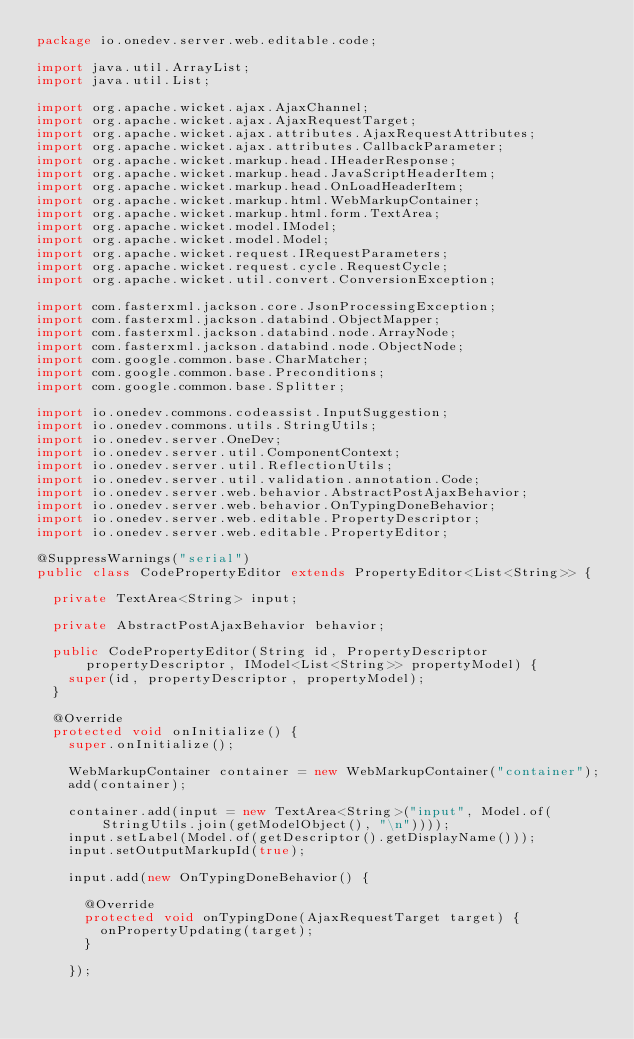Convert code to text. <code><loc_0><loc_0><loc_500><loc_500><_Java_>package io.onedev.server.web.editable.code;

import java.util.ArrayList;
import java.util.List;

import org.apache.wicket.ajax.AjaxChannel;
import org.apache.wicket.ajax.AjaxRequestTarget;
import org.apache.wicket.ajax.attributes.AjaxRequestAttributes;
import org.apache.wicket.ajax.attributes.CallbackParameter;
import org.apache.wicket.markup.head.IHeaderResponse;
import org.apache.wicket.markup.head.JavaScriptHeaderItem;
import org.apache.wicket.markup.head.OnLoadHeaderItem;
import org.apache.wicket.markup.html.WebMarkupContainer;
import org.apache.wicket.markup.html.form.TextArea;
import org.apache.wicket.model.IModel;
import org.apache.wicket.model.Model;
import org.apache.wicket.request.IRequestParameters;
import org.apache.wicket.request.cycle.RequestCycle;
import org.apache.wicket.util.convert.ConversionException;

import com.fasterxml.jackson.core.JsonProcessingException;
import com.fasterxml.jackson.databind.ObjectMapper;
import com.fasterxml.jackson.databind.node.ArrayNode;
import com.fasterxml.jackson.databind.node.ObjectNode;
import com.google.common.base.CharMatcher;
import com.google.common.base.Preconditions;
import com.google.common.base.Splitter;

import io.onedev.commons.codeassist.InputSuggestion;
import io.onedev.commons.utils.StringUtils;
import io.onedev.server.OneDev;
import io.onedev.server.util.ComponentContext;
import io.onedev.server.util.ReflectionUtils;
import io.onedev.server.util.validation.annotation.Code;
import io.onedev.server.web.behavior.AbstractPostAjaxBehavior;
import io.onedev.server.web.behavior.OnTypingDoneBehavior;
import io.onedev.server.web.editable.PropertyDescriptor;
import io.onedev.server.web.editable.PropertyEditor;

@SuppressWarnings("serial")
public class CodePropertyEditor extends PropertyEditor<List<String>> {

	private TextArea<String> input;
	
	private AbstractPostAjaxBehavior behavior;
	
	public CodePropertyEditor(String id, PropertyDescriptor propertyDescriptor, IModel<List<String>> propertyModel) {
		super(id, propertyDescriptor, propertyModel);
	}

	@Override
	protected void onInitialize() {
		super.onInitialize();
		
		WebMarkupContainer container = new WebMarkupContainer("container");
		add(container);
		
		container.add(input = new TextArea<String>("input", Model.of(StringUtils.join(getModelObject(), "\n"))));
		input.setLabel(Model.of(getDescriptor().getDisplayName()));		
		input.setOutputMarkupId(true);

		input.add(new OnTypingDoneBehavior() {

			@Override
			protected void onTypingDone(AjaxRequestTarget target) {
				onPropertyUpdating(target);
			}
			
		});</code> 